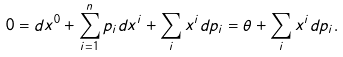<formula> <loc_0><loc_0><loc_500><loc_500>0 = d x ^ { 0 } + \sum _ { i = 1 } ^ { n } p _ { i } d x ^ { i } + \sum _ { i } x ^ { i } d p _ { i } = \theta + \sum _ { i } x ^ { i } d p _ { i } .</formula> 